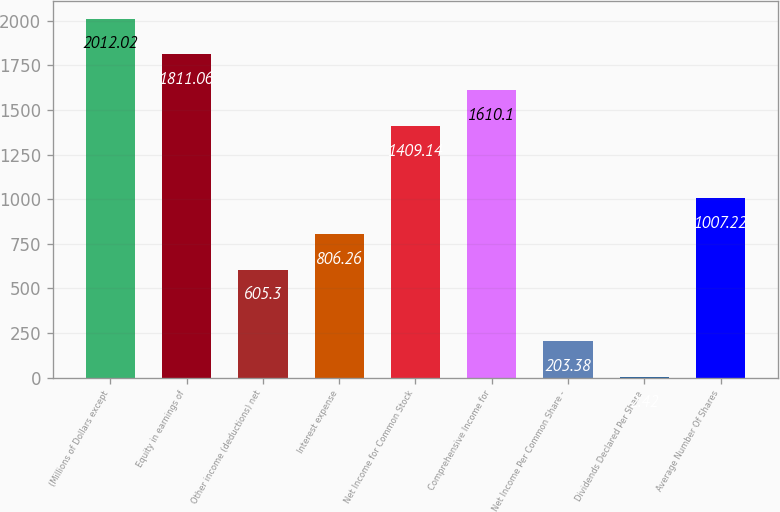<chart> <loc_0><loc_0><loc_500><loc_500><bar_chart><fcel>(Millions of Dollars except<fcel>Equity in earnings of<fcel>Other income (deductions) net<fcel>Interest expense<fcel>Net Income for Common Stock<fcel>Comprehensive Income for<fcel>Net Income Per Common Share -<fcel>Dividends Declared Per Share<fcel>Average Number Of Shares<nl><fcel>2012.02<fcel>1811.06<fcel>605.3<fcel>806.26<fcel>1409.14<fcel>1610.1<fcel>203.38<fcel>2.42<fcel>1007.22<nl></chart> 